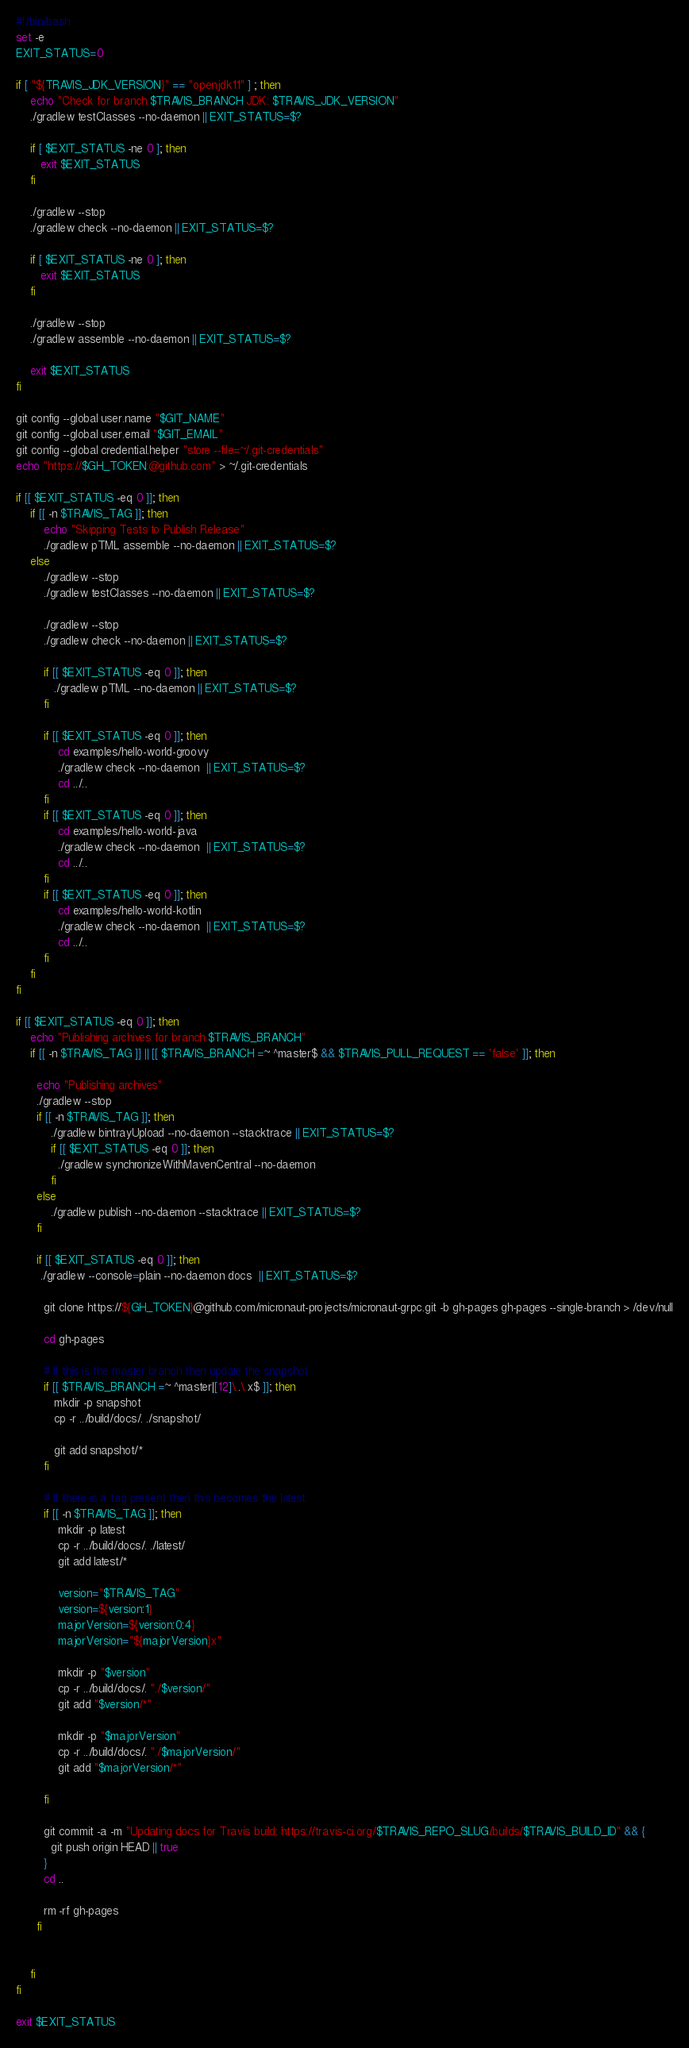Convert code to text. <code><loc_0><loc_0><loc_500><loc_500><_Bash_>#!/bin/bash
set -e
EXIT_STATUS=0

if [ "${TRAVIS_JDK_VERSION}" == "openjdk11" ] ; then
    echo "Check for branch $TRAVIS_BRANCH JDK: $TRAVIS_JDK_VERSION"
    ./gradlew testClasses --no-daemon || EXIT_STATUS=$?

    if [ $EXIT_STATUS -ne 0 ]; then
       exit $EXIT_STATUS
    fi

    ./gradlew --stop
    ./gradlew check --no-daemon || EXIT_STATUS=$?

    if [ $EXIT_STATUS -ne 0 ]; then
       exit $EXIT_STATUS
    fi

    ./gradlew --stop
    ./gradlew assemble --no-daemon || EXIT_STATUS=$?

    exit $EXIT_STATUS
fi

git config --global user.name "$GIT_NAME"
git config --global user.email "$GIT_EMAIL"
git config --global credential.helper "store --file=~/.git-credentials"
echo "https://$GH_TOKEN:@github.com" > ~/.git-credentials

if [[ $EXIT_STATUS -eq 0 ]]; then
    if [[ -n $TRAVIS_TAG ]]; then
        echo "Skipping Tests to Publish Release"
        ./gradlew pTML assemble --no-daemon || EXIT_STATUS=$?
    else
        ./gradlew --stop
        ./gradlew testClasses --no-daemon || EXIT_STATUS=$?

        ./gradlew --stop
        ./gradlew check --no-daemon || EXIT_STATUS=$?

        if [[ $EXIT_STATUS -eq 0 ]]; then
           ./gradlew pTML --no-daemon || EXIT_STATUS=$?
        fi

        if [[ $EXIT_STATUS -eq 0 ]]; then
            cd examples/hello-world-groovy
            ./gradlew check --no-daemon  || EXIT_STATUS=$?
            cd ../..
        fi
        if [[ $EXIT_STATUS -eq 0 ]]; then
            cd examples/hello-world-java
            ./gradlew check --no-daemon  || EXIT_STATUS=$?
            cd ../..
        fi
        if [[ $EXIT_STATUS -eq 0 ]]; then
            cd examples/hello-world-kotlin
            ./gradlew check --no-daemon  || EXIT_STATUS=$?
            cd ../..
        fi
    fi
fi

if [[ $EXIT_STATUS -eq 0 ]]; then
    echo "Publishing archives for branch $TRAVIS_BRANCH"
    if [[ -n $TRAVIS_TAG ]] || [[ $TRAVIS_BRANCH =~ ^master$ && $TRAVIS_PULL_REQUEST == 'false' ]]; then

      echo "Publishing archives"
      ./gradlew --stop
      if [[ -n $TRAVIS_TAG ]]; then
          ./gradlew bintrayUpload --no-daemon --stacktrace || EXIT_STATUS=$?
          if [[ $EXIT_STATUS -eq 0 ]]; then
            ./gradlew synchronizeWithMavenCentral --no-daemon
          fi
      else
          ./gradlew publish --no-daemon --stacktrace || EXIT_STATUS=$?
      fi

      if [[ $EXIT_STATUS -eq 0 ]]; then
       ./gradlew --console=plain --no-daemon docs  || EXIT_STATUS=$?

        git clone https://${GH_TOKEN}@github.com/micronaut-projects/micronaut-grpc.git -b gh-pages gh-pages --single-branch > /dev/null

        cd gh-pages

        # If this is the master branch then update the snapshot
        if [[ $TRAVIS_BRANCH =~ ^master|[12]\..\.x$ ]]; then
           mkdir -p snapshot
           cp -r ../build/docs/. ./snapshot/

           git add snapshot/*
        fi

        # If there is a tag present then this becomes the latest
        if [[ -n $TRAVIS_TAG ]]; then
            mkdir -p latest
            cp -r ../build/docs/. ./latest/
            git add latest/*

            version="$TRAVIS_TAG"
            version=${version:1}
            majorVersion=${version:0:4}
            majorVersion="${majorVersion}x"

            mkdir -p "$version"
            cp -r ../build/docs/. "./$version/"
            git add "$version/*"

            mkdir -p "$majorVersion"
            cp -r ../build/docs/. "./$majorVersion/"
            git add "$majorVersion/*"

        fi

        git commit -a -m "Updating docs for Travis build: https://travis-ci.org/$TRAVIS_REPO_SLUG/builds/$TRAVIS_BUILD_ID" && {
          git push origin HEAD || true
        }
        cd ..

        rm -rf gh-pages
      fi
 

    fi
fi

exit $EXIT_STATUS
</code> 